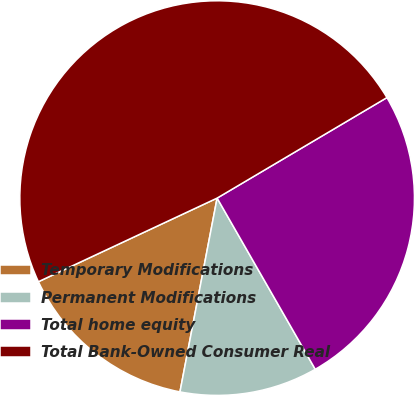Convert chart to OTSL. <chart><loc_0><loc_0><loc_500><loc_500><pie_chart><fcel>Temporary Modifications<fcel>Permanent Modifications<fcel>Total home equity<fcel>Total Bank-Owned Consumer Real<nl><fcel>15.02%<fcel>11.3%<fcel>25.22%<fcel>48.46%<nl></chart> 